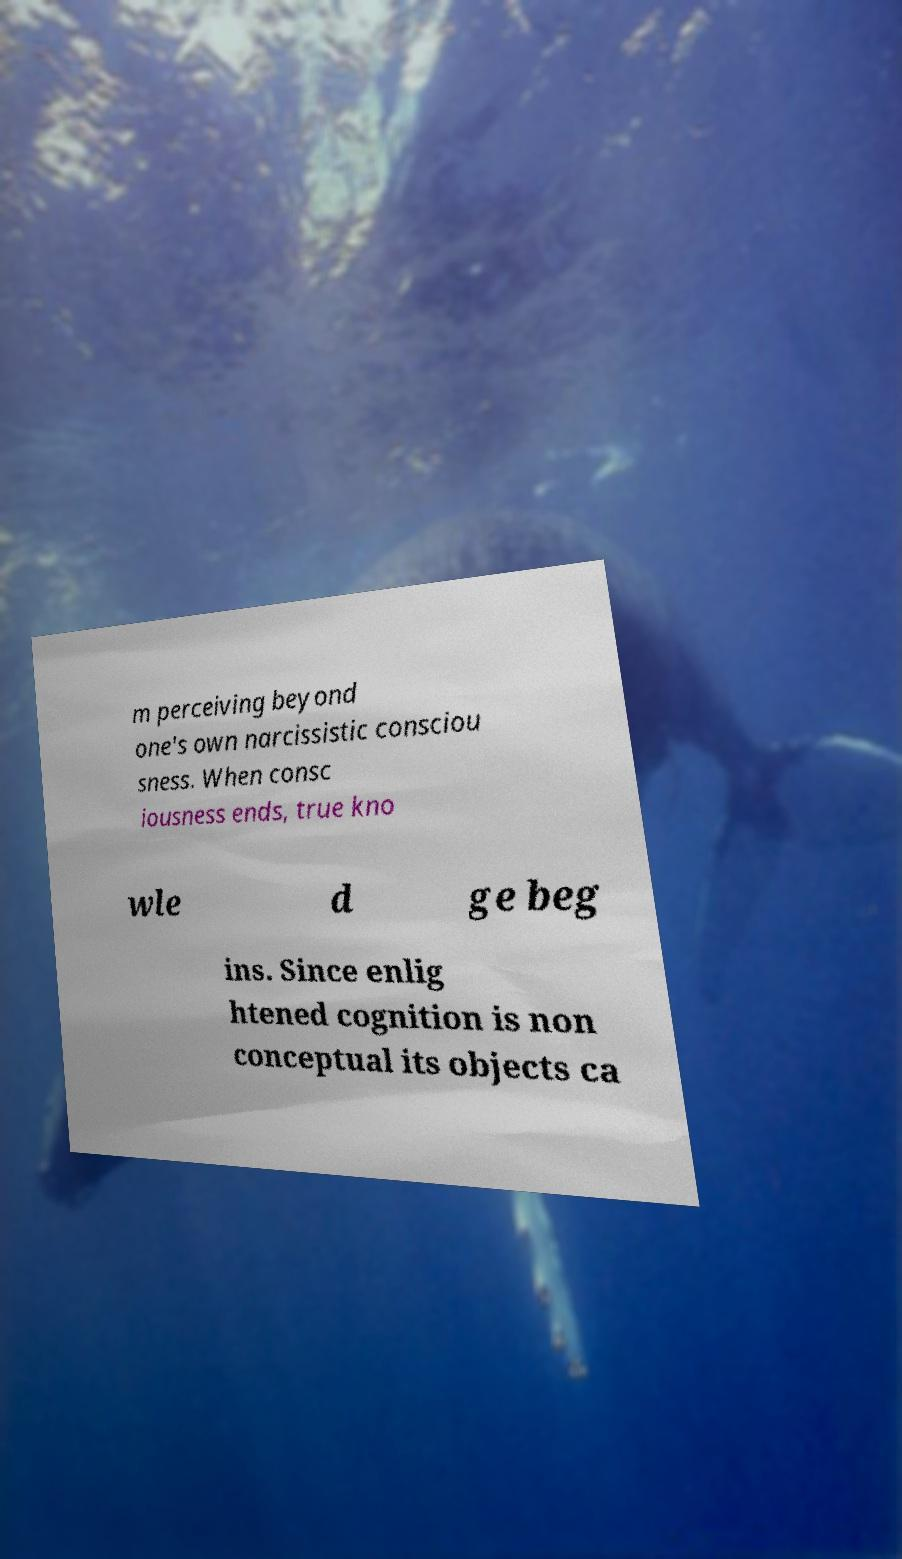Please read and relay the text visible in this image. What does it say? m perceiving beyond one's own narcissistic consciou sness. When consc iousness ends, true kno wle d ge beg ins. Since enlig htened cognition is non conceptual its objects ca 